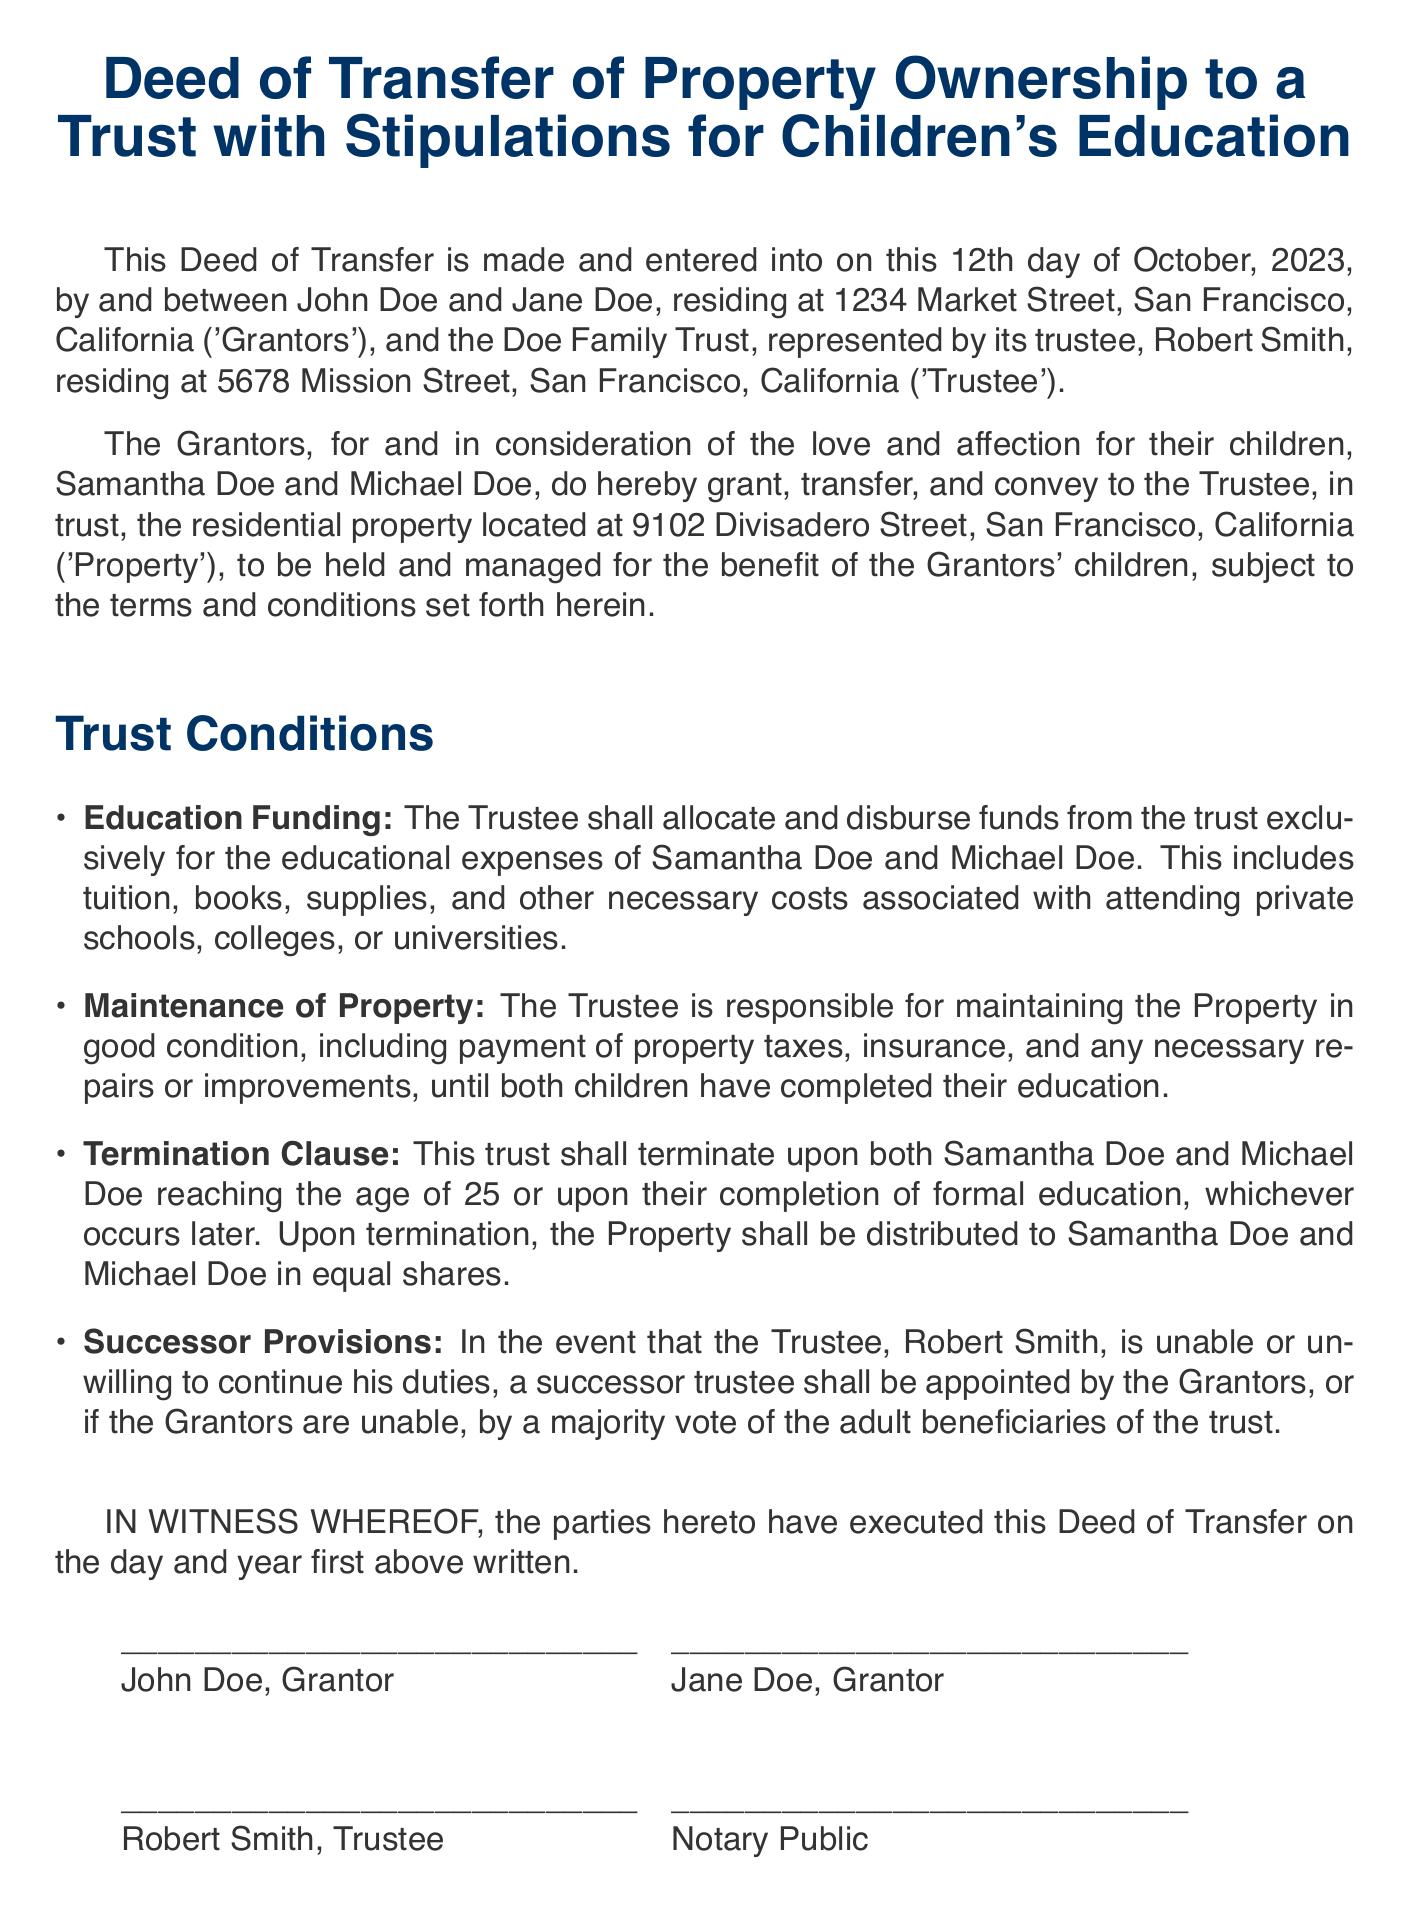What is the date of the Deed of Transfer? The date of the Deed is explicitly stated in the document as the 12th day of October, 2023.
Answer: October 12, 2023 Who are the Grantors in this Deed? The names of the Grantors are listed at the beginning of the document as John Doe and Jane Doe.
Answer: John Doe and Jane Doe What is the address of the property being transferred? The specific address of the property is provided in the document as 9102 Divisadero Street, San Francisco, California.
Answer: 9102 Divisadero Street, San Francisco, California What are the names of the children for whom the trust is established? The document mentions the children as Samantha Doe and Michael Doe.
Answer: Samantha Doe and Michael Doe What is the age at which the trust will terminate? The document states that the trust shall terminate when both children reach the age of 25.
Answer: 25 What responsibilities does the Trustee have concerning the Property? The Trustee is responsible for maintaining the Property in good condition and ensuring payment of property taxes and insurance until the completion of the children's education.
Answer: Maintaining the Property Who is the Trustee named in the Deed? The Trustee is identified in the document as Robert Smith.
Answer: Robert Smith What happens upon termination of the trust? Upon termination, the Property shall be distributed to Samantha Doe and Michael Doe in equal shares.
Answer: Distributed in equal shares What is the primary purpose of the trust established in this Deed? The main purpose of the trust is to allocate and disburse funds for the educational expenses of the Grantors' children.
Answer: Educational expenses 